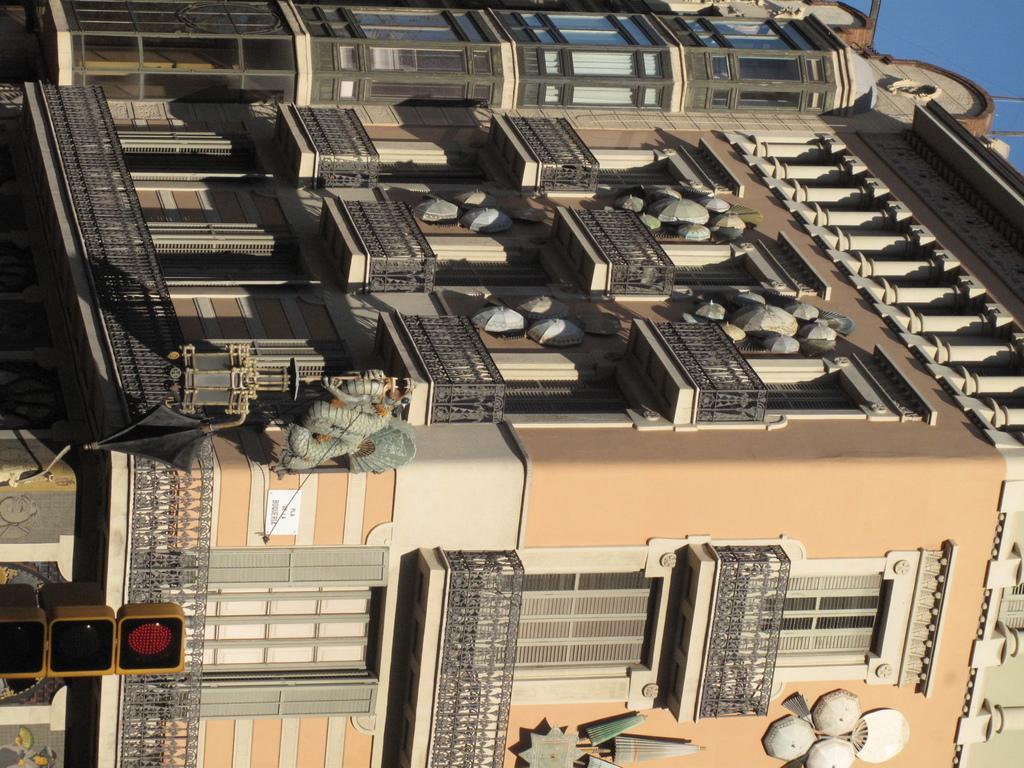Describe this image in one or two sentences. In this picture we can see there are traffic signals and a building. Behind the building there is a sky. 